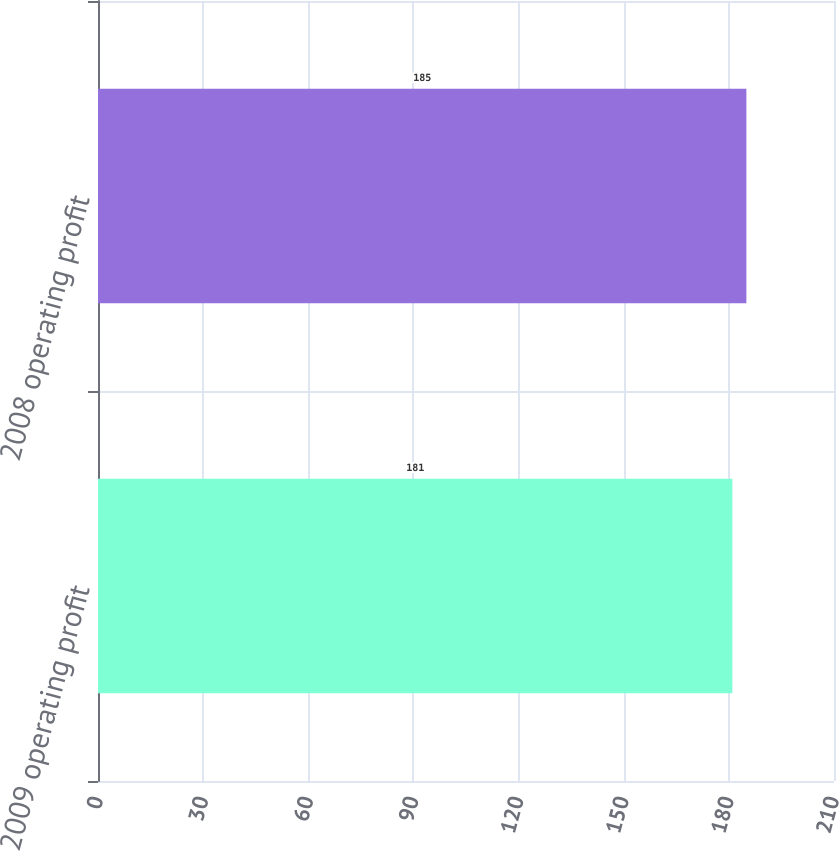Convert chart. <chart><loc_0><loc_0><loc_500><loc_500><bar_chart><fcel>2009 operating profit<fcel>2008 operating profit<nl><fcel>181<fcel>185<nl></chart> 